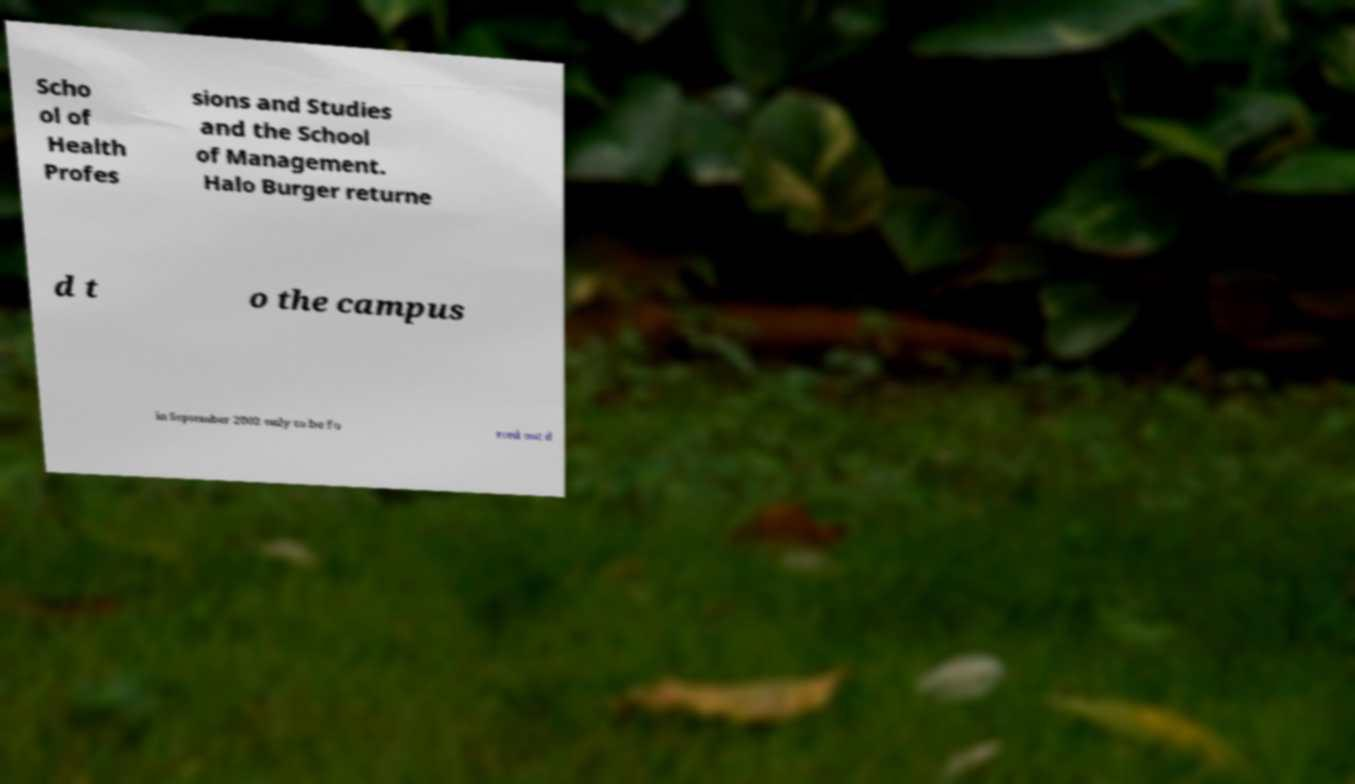Can you accurately transcribe the text from the provided image for me? Scho ol of Health Profes sions and Studies and the School of Management. Halo Burger returne d t o the campus in September 2002 only to be fo rced out d 